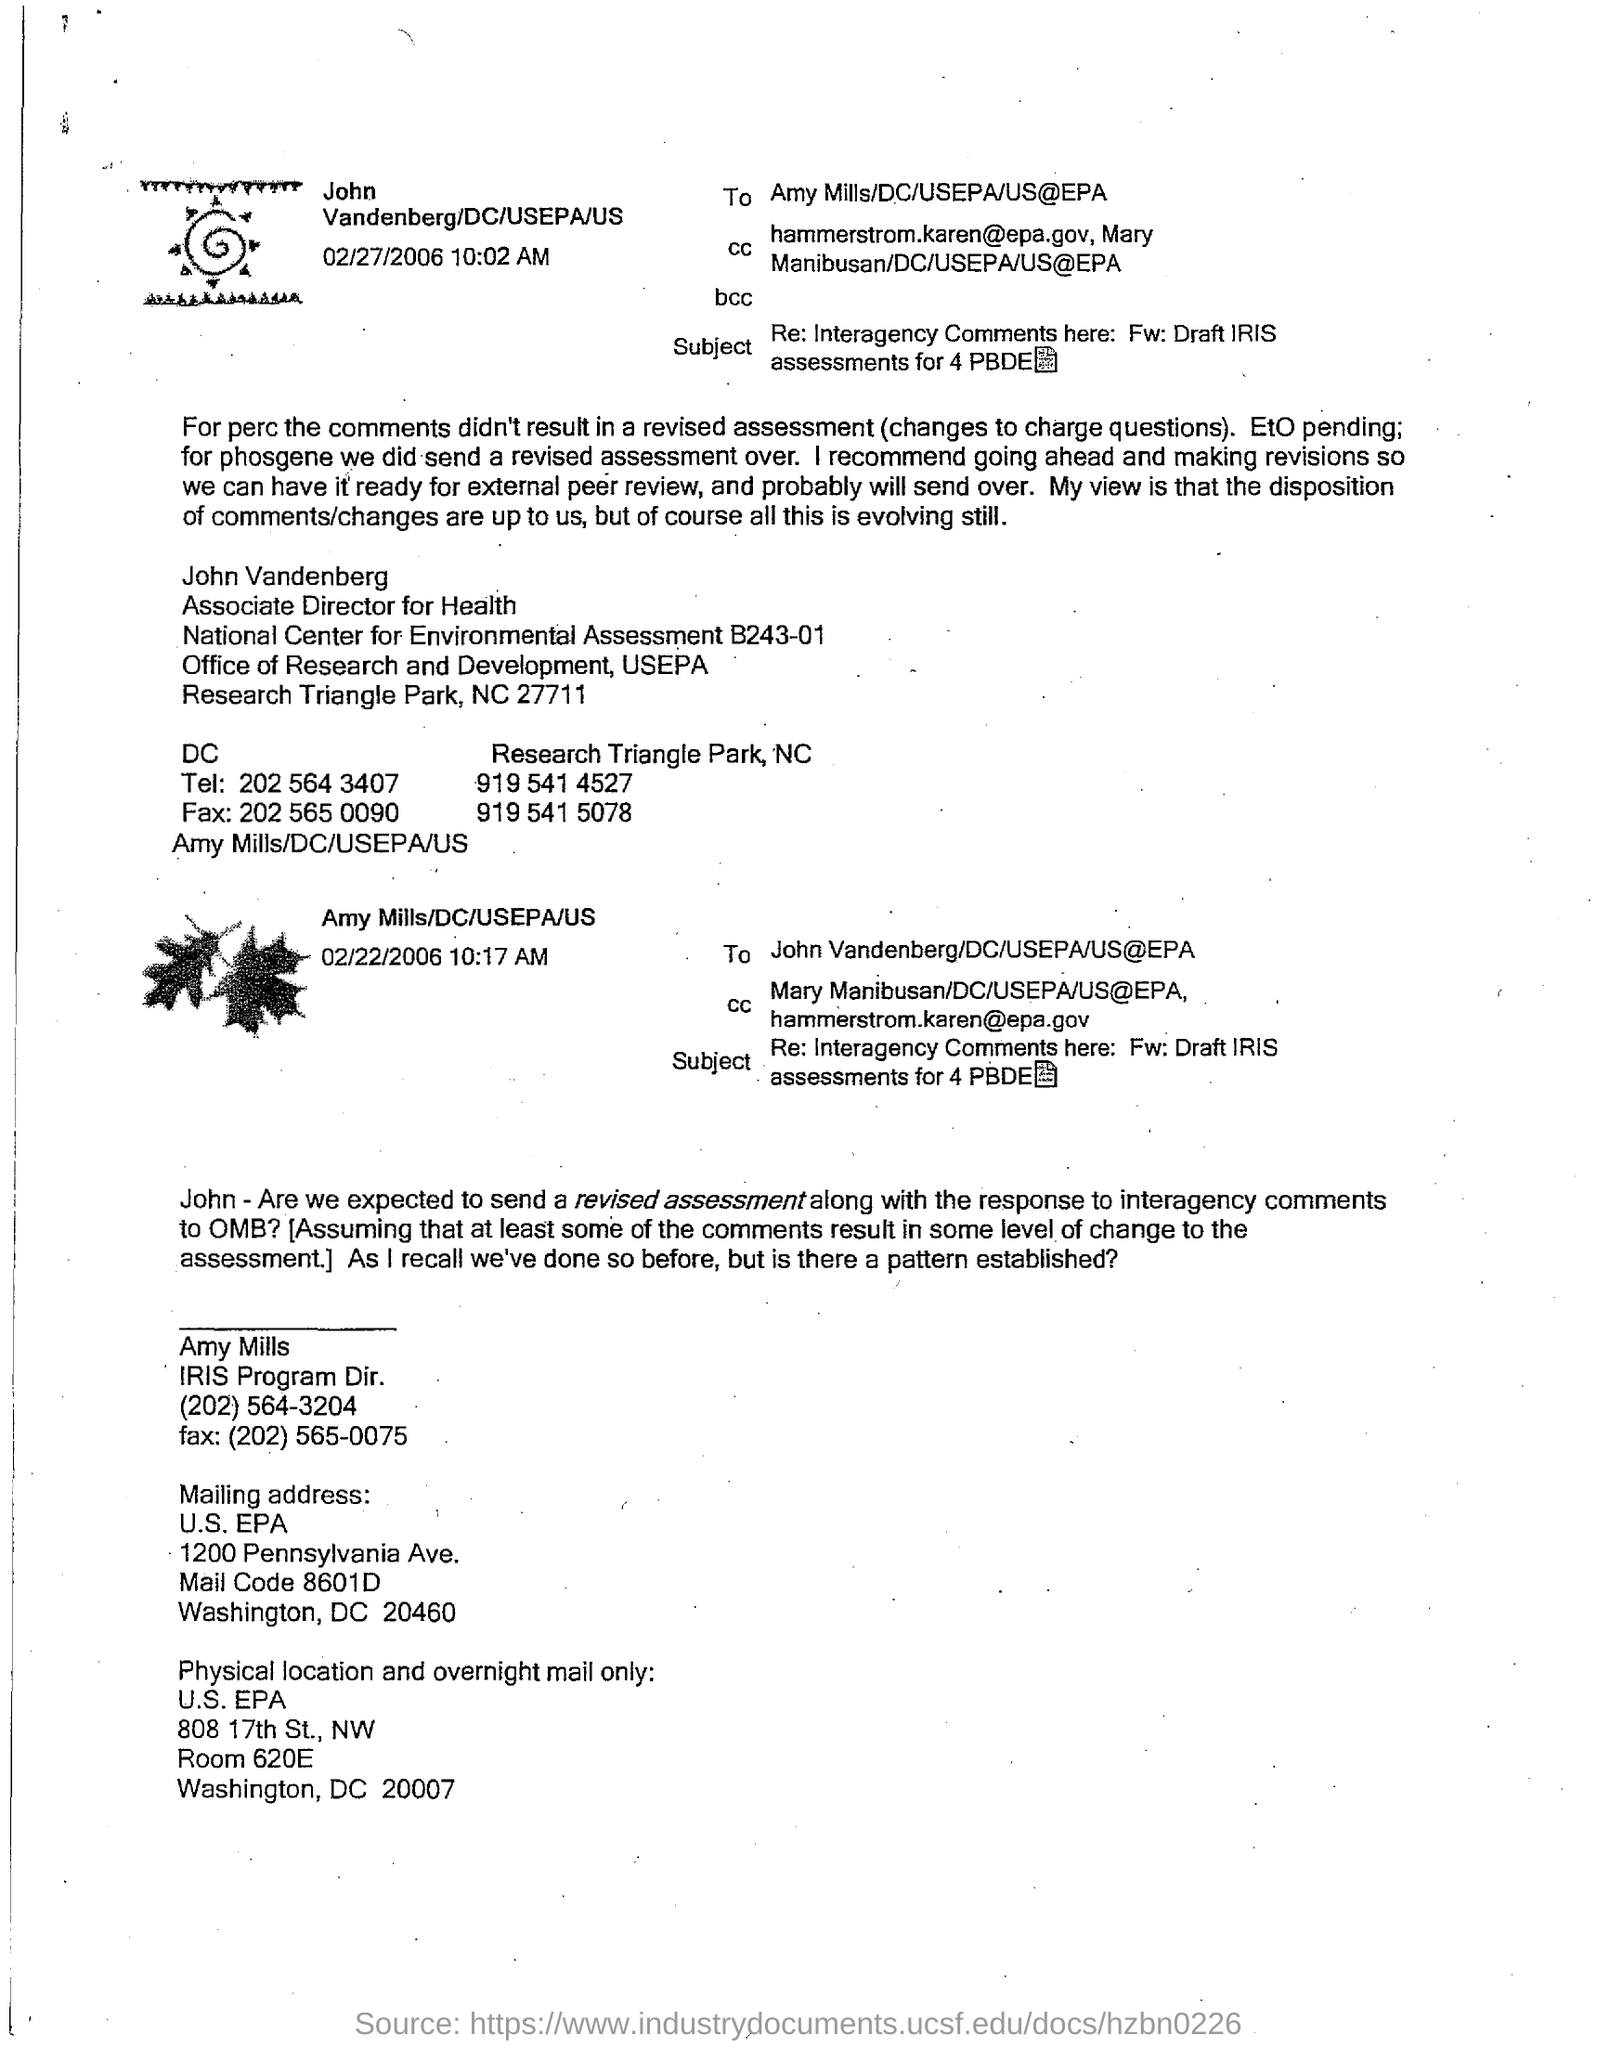What is the date and time mentioned near the top left image?
Your response must be concise. 02/27/2006 10:02 AM. Who is the Associate Director for Health?
Offer a very short reply. John Vandenberg. What is the FAX number of John Vandenberg at DC ?
Ensure brevity in your answer.  202 565 0090. What is the designation of 'Amy Mills' ?
Your answer should be compact. IRIS Program Dir. What is the Mail Code given in Mailing address of of 'Amy Mills' ?
Give a very brief answer. 8601D. 